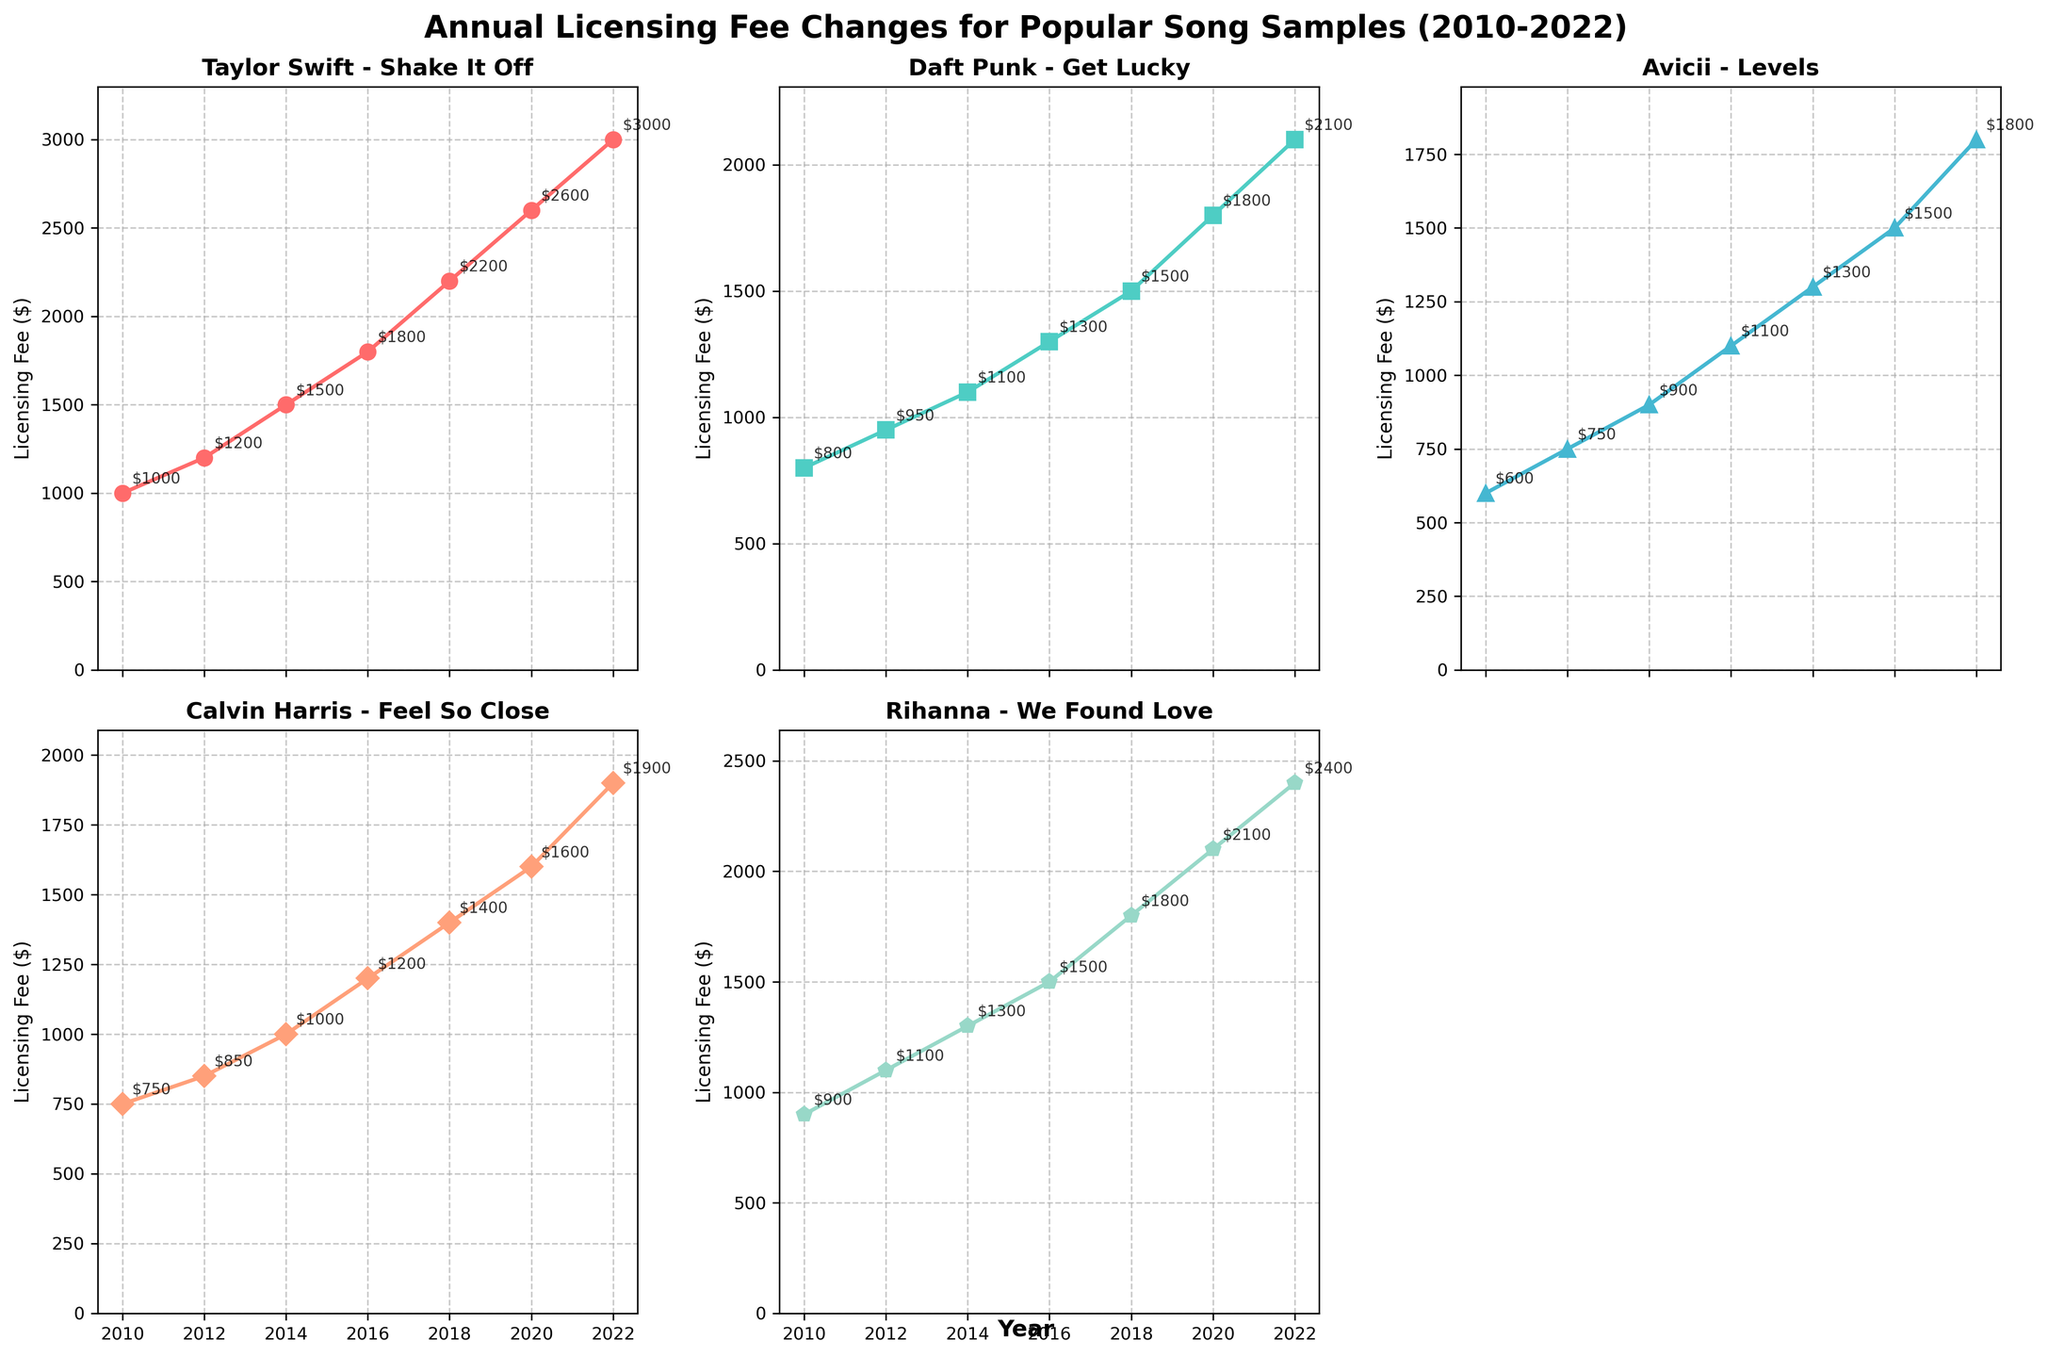What's the overall title of the figure? The overall title is typically displayed at the top, center of the figure in bold. Identify and read the text displayed there.
Answer: Annual Licensing Fee Changes for Popular Song Samples (2010-2022) How many songs are analyzed in this figure? Count the number of subplots or individual lines representing different songs in the figure. There are 5 different songs analyzed.
Answer: 5 Which song has the highest licensing fee in 2022? Locate the data points for the year 2022 on each subplot. Identify which subplot has the highest value in 2022.
Answer: Taylor Swift - Shake It Off By how much did the licensing fee for "Daft Punk - Get Lucky" increase from 2010 to 2022? Find the data points for "Daft Punk - Get Lucky" in 2010 and 2022. Subtract the 2010 value from the 2022 value: 2100 - 800 = 1300.
Answer: 1300 What trend do you observe in the licensing fees for "Rihanna - We Found Love" from 2010 to 2022? Examine the plot for "Rihanna - We Found Love" from 2010 to 2022 and observe the changes in the data points. The fees show a consistent upward trend.
Answer: Consistent upward trend Which song experienced the smallest relative increase in licensing fee from 2010 to 2022? Calculate the relative increase for each song using (Fee in 2022 - Fee in 2010) / Fee in 2010. Compare the values for all songs.
Answer: Avicii - Levels What is the average licensing fee for "Calvin Harris - Feel So Close" between 2010 and 2022? Sum the licensing fees for "Calvin Harris - Feel So Close" from 2010 to 2022 and divide by the number of data points (7 years). (750 + 850 + 1000 + 1200 + 1400 + 1600 + 1900) / 7 = 1230.
Answer: 1230 In which year did "Taylor Swift - Shake It Off" show the biggest year-over-year increase in licensing fee? Calculate the year-over-year increase for each pair of consecutive years and identify the maximum. 2018-2016: 2200-1800= 400, 2020-2018: 2600-2200=400, 2022-2020: 3000-2600=400. Therefore, 2016-2014: 1800-1500=300 is the smallest.
Answer: 2018 Which song had the most consistent increase in licensing fees each year? Examine the slopes of the lines for all songs. Identify the one with the most evenly spaced increases.
Answer: Avicii - Levels How does the increase in licensing fees for "Calvin Harris - Feel So Close" compare to "Rihanna - We Found Love" from 2016 to 2020? Find the fees for both songs in 2016 and 2020. Subtract the 2016 value from the 2020 value for both songs: Calvin Harris: 1600-1200=400, Rihanna: 2100-1500=600. Compare the differences.
Answer: Rihanna - We Found Love increased more 